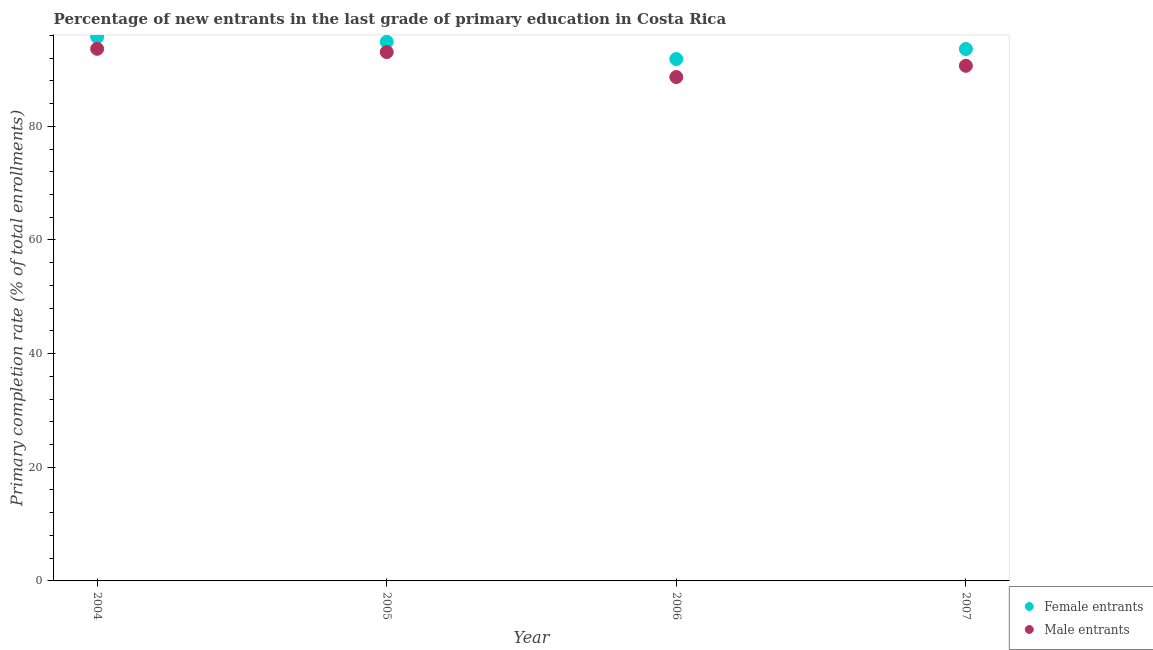How many different coloured dotlines are there?
Your answer should be very brief. 2. What is the primary completion rate of female entrants in 2006?
Keep it short and to the point. 91.83. Across all years, what is the maximum primary completion rate of male entrants?
Provide a short and direct response. 93.63. Across all years, what is the minimum primary completion rate of male entrants?
Your answer should be very brief. 88.66. In which year was the primary completion rate of male entrants maximum?
Give a very brief answer. 2004. What is the total primary completion rate of male entrants in the graph?
Your answer should be compact. 365.99. What is the difference between the primary completion rate of female entrants in 2004 and that in 2006?
Keep it short and to the point. 3.9. What is the difference between the primary completion rate of male entrants in 2006 and the primary completion rate of female entrants in 2004?
Keep it short and to the point. -7.07. What is the average primary completion rate of female entrants per year?
Give a very brief answer. 94. In the year 2005, what is the difference between the primary completion rate of male entrants and primary completion rate of female entrants?
Your response must be concise. -1.8. What is the ratio of the primary completion rate of female entrants in 2004 to that in 2007?
Ensure brevity in your answer.  1.02. Is the primary completion rate of male entrants in 2004 less than that in 2005?
Keep it short and to the point. No. What is the difference between the highest and the second highest primary completion rate of female entrants?
Your response must be concise. 0.87. What is the difference between the highest and the lowest primary completion rate of female entrants?
Give a very brief answer. 3.9. Does the primary completion rate of female entrants monotonically increase over the years?
Ensure brevity in your answer.  No. How many dotlines are there?
Keep it short and to the point. 2. How many years are there in the graph?
Provide a succinct answer. 4. Are the values on the major ticks of Y-axis written in scientific E-notation?
Provide a succinct answer. No. Does the graph contain grids?
Your response must be concise. No. Where does the legend appear in the graph?
Give a very brief answer. Bottom right. What is the title of the graph?
Offer a very short reply. Percentage of new entrants in the last grade of primary education in Costa Rica. What is the label or title of the X-axis?
Keep it short and to the point. Year. What is the label or title of the Y-axis?
Provide a short and direct response. Primary completion rate (% of total enrollments). What is the Primary completion rate (% of total enrollments) in Female entrants in 2004?
Your answer should be very brief. 95.73. What is the Primary completion rate (% of total enrollments) of Male entrants in 2004?
Give a very brief answer. 93.63. What is the Primary completion rate (% of total enrollments) of Female entrants in 2005?
Offer a very short reply. 94.86. What is the Primary completion rate (% of total enrollments) of Male entrants in 2005?
Keep it short and to the point. 93.06. What is the Primary completion rate (% of total enrollments) in Female entrants in 2006?
Your answer should be very brief. 91.83. What is the Primary completion rate (% of total enrollments) in Male entrants in 2006?
Your answer should be compact. 88.66. What is the Primary completion rate (% of total enrollments) in Female entrants in 2007?
Provide a succinct answer. 93.6. What is the Primary completion rate (% of total enrollments) in Male entrants in 2007?
Give a very brief answer. 90.64. Across all years, what is the maximum Primary completion rate (% of total enrollments) in Female entrants?
Your answer should be very brief. 95.73. Across all years, what is the maximum Primary completion rate (% of total enrollments) of Male entrants?
Offer a terse response. 93.63. Across all years, what is the minimum Primary completion rate (% of total enrollments) in Female entrants?
Your response must be concise. 91.83. Across all years, what is the minimum Primary completion rate (% of total enrollments) in Male entrants?
Your response must be concise. 88.66. What is the total Primary completion rate (% of total enrollments) in Female entrants in the graph?
Your answer should be compact. 376.02. What is the total Primary completion rate (% of total enrollments) in Male entrants in the graph?
Offer a terse response. 365.99. What is the difference between the Primary completion rate (% of total enrollments) in Female entrants in 2004 and that in 2005?
Your answer should be compact. 0.87. What is the difference between the Primary completion rate (% of total enrollments) in Male entrants in 2004 and that in 2005?
Keep it short and to the point. 0.57. What is the difference between the Primary completion rate (% of total enrollments) of Female entrants in 2004 and that in 2006?
Make the answer very short. 3.9. What is the difference between the Primary completion rate (% of total enrollments) in Male entrants in 2004 and that in 2006?
Offer a terse response. 4.97. What is the difference between the Primary completion rate (% of total enrollments) of Female entrants in 2004 and that in 2007?
Ensure brevity in your answer.  2.13. What is the difference between the Primary completion rate (% of total enrollments) in Male entrants in 2004 and that in 2007?
Your response must be concise. 2.99. What is the difference between the Primary completion rate (% of total enrollments) of Female entrants in 2005 and that in 2006?
Keep it short and to the point. 3.03. What is the difference between the Primary completion rate (% of total enrollments) of Male entrants in 2005 and that in 2006?
Your response must be concise. 4.39. What is the difference between the Primary completion rate (% of total enrollments) in Female entrants in 2005 and that in 2007?
Provide a succinct answer. 1.26. What is the difference between the Primary completion rate (% of total enrollments) of Male entrants in 2005 and that in 2007?
Your response must be concise. 2.41. What is the difference between the Primary completion rate (% of total enrollments) of Female entrants in 2006 and that in 2007?
Ensure brevity in your answer.  -1.77. What is the difference between the Primary completion rate (% of total enrollments) of Male entrants in 2006 and that in 2007?
Offer a terse response. -1.98. What is the difference between the Primary completion rate (% of total enrollments) in Female entrants in 2004 and the Primary completion rate (% of total enrollments) in Male entrants in 2005?
Your response must be concise. 2.67. What is the difference between the Primary completion rate (% of total enrollments) in Female entrants in 2004 and the Primary completion rate (% of total enrollments) in Male entrants in 2006?
Provide a succinct answer. 7.07. What is the difference between the Primary completion rate (% of total enrollments) in Female entrants in 2004 and the Primary completion rate (% of total enrollments) in Male entrants in 2007?
Your answer should be compact. 5.09. What is the difference between the Primary completion rate (% of total enrollments) of Female entrants in 2005 and the Primary completion rate (% of total enrollments) of Male entrants in 2006?
Your answer should be very brief. 6.2. What is the difference between the Primary completion rate (% of total enrollments) in Female entrants in 2005 and the Primary completion rate (% of total enrollments) in Male entrants in 2007?
Your response must be concise. 4.22. What is the difference between the Primary completion rate (% of total enrollments) in Female entrants in 2006 and the Primary completion rate (% of total enrollments) in Male entrants in 2007?
Make the answer very short. 1.19. What is the average Primary completion rate (% of total enrollments) of Female entrants per year?
Your answer should be very brief. 94. What is the average Primary completion rate (% of total enrollments) of Male entrants per year?
Ensure brevity in your answer.  91.5. In the year 2004, what is the difference between the Primary completion rate (% of total enrollments) of Female entrants and Primary completion rate (% of total enrollments) of Male entrants?
Make the answer very short. 2.1. In the year 2005, what is the difference between the Primary completion rate (% of total enrollments) of Female entrants and Primary completion rate (% of total enrollments) of Male entrants?
Keep it short and to the point. 1.8. In the year 2006, what is the difference between the Primary completion rate (% of total enrollments) in Female entrants and Primary completion rate (% of total enrollments) in Male entrants?
Provide a short and direct response. 3.17. In the year 2007, what is the difference between the Primary completion rate (% of total enrollments) in Female entrants and Primary completion rate (% of total enrollments) in Male entrants?
Provide a succinct answer. 2.95. What is the ratio of the Primary completion rate (% of total enrollments) of Female entrants in 2004 to that in 2005?
Offer a terse response. 1.01. What is the ratio of the Primary completion rate (% of total enrollments) of Female entrants in 2004 to that in 2006?
Your answer should be compact. 1.04. What is the ratio of the Primary completion rate (% of total enrollments) in Male entrants in 2004 to that in 2006?
Give a very brief answer. 1.06. What is the ratio of the Primary completion rate (% of total enrollments) in Female entrants in 2004 to that in 2007?
Give a very brief answer. 1.02. What is the ratio of the Primary completion rate (% of total enrollments) of Male entrants in 2004 to that in 2007?
Give a very brief answer. 1.03. What is the ratio of the Primary completion rate (% of total enrollments) in Female entrants in 2005 to that in 2006?
Keep it short and to the point. 1.03. What is the ratio of the Primary completion rate (% of total enrollments) in Male entrants in 2005 to that in 2006?
Your response must be concise. 1.05. What is the ratio of the Primary completion rate (% of total enrollments) in Female entrants in 2005 to that in 2007?
Offer a very short reply. 1.01. What is the ratio of the Primary completion rate (% of total enrollments) of Male entrants in 2005 to that in 2007?
Provide a short and direct response. 1.03. What is the ratio of the Primary completion rate (% of total enrollments) in Female entrants in 2006 to that in 2007?
Ensure brevity in your answer.  0.98. What is the ratio of the Primary completion rate (% of total enrollments) in Male entrants in 2006 to that in 2007?
Make the answer very short. 0.98. What is the difference between the highest and the second highest Primary completion rate (% of total enrollments) in Female entrants?
Offer a terse response. 0.87. What is the difference between the highest and the second highest Primary completion rate (% of total enrollments) in Male entrants?
Make the answer very short. 0.57. What is the difference between the highest and the lowest Primary completion rate (% of total enrollments) of Female entrants?
Your answer should be very brief. 3.9. What is the difference between the highest and the lowest Primary completion rate (% of total enrollments) in Male entrants?
Make the answer very short. 4.97. 